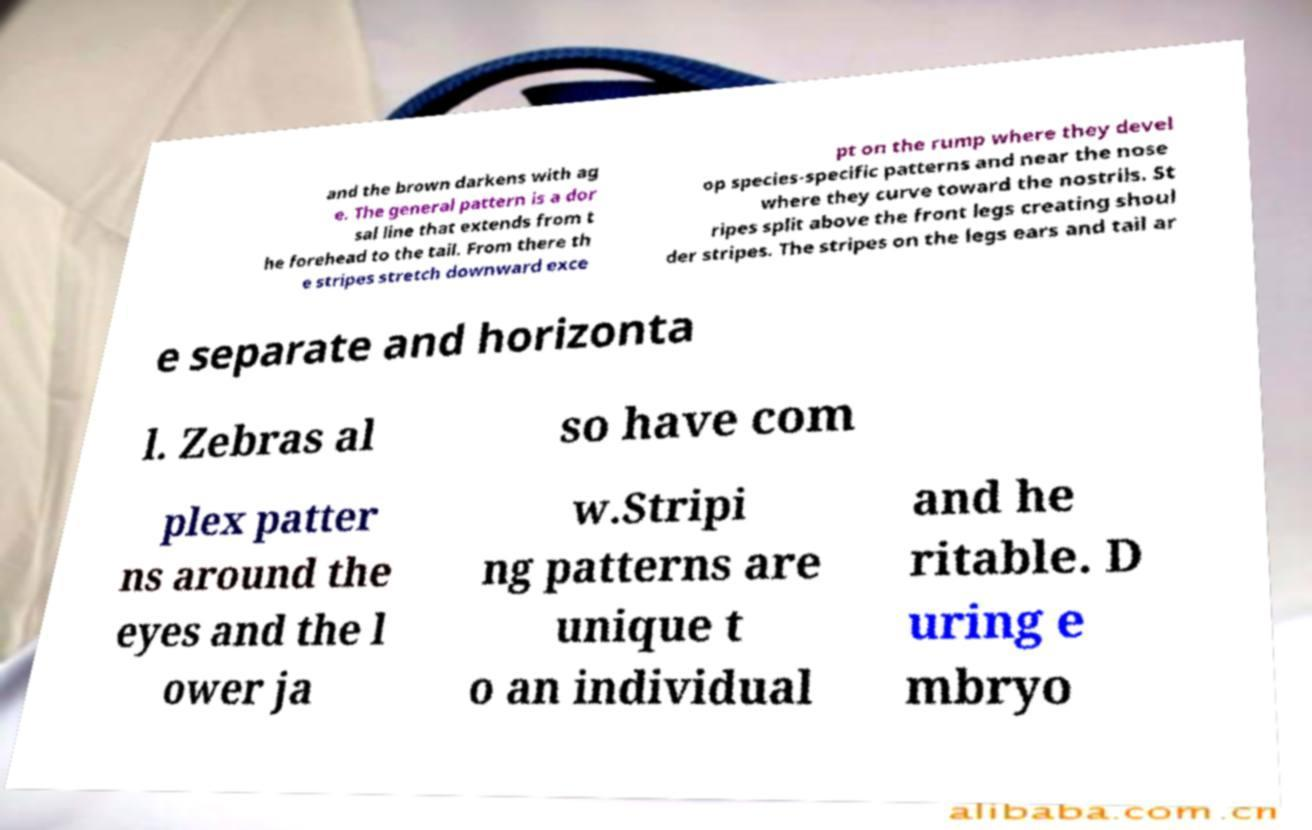Please read and relay the text visible in this image. What does it say? and the brown darkens with ag e. The general pattern is a dor sal line that extends from t he forehead to the tail. From there th e stripes stretch downward exce pt on the rump where they devel op species-specific patterns and near the nose where they curve toward the nostrils. St ripes split above the front legs creating shoul der stripes. The stripes on the legs ears and tail ar e separate and horizonta l. Zebras al so have com plex patter ns around the eyes and the l ower ja w.Stripi ng patterns are unique t o an individual and he ritable. D uring e mbryo 